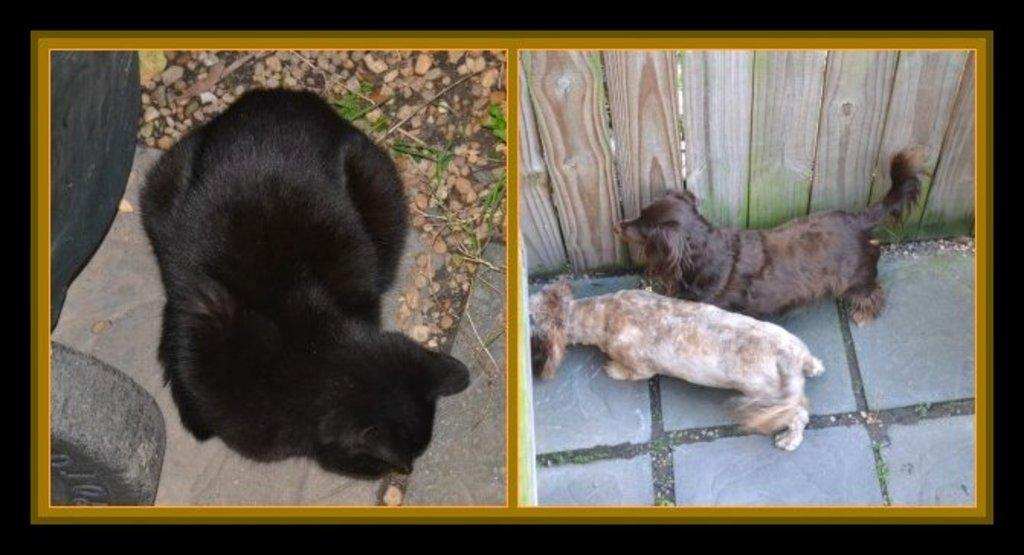What is there is a frame on a black surface in the image, what is inside the frame? The frame contains images of animals, stones, a wall, and other objects. Can you describe the background of the image? The background of the image is a black surface. What type of objects can be seen in the images within the frame? The images within the frame depict animals, stones, a wall, and other objects. Is there any blood visible in the images within the frame? No, there is no blood visible in the images within the frame. Can you see any mist surrounding the objects in the images within the frame? No, there is no mist visible in the images within the frame. 